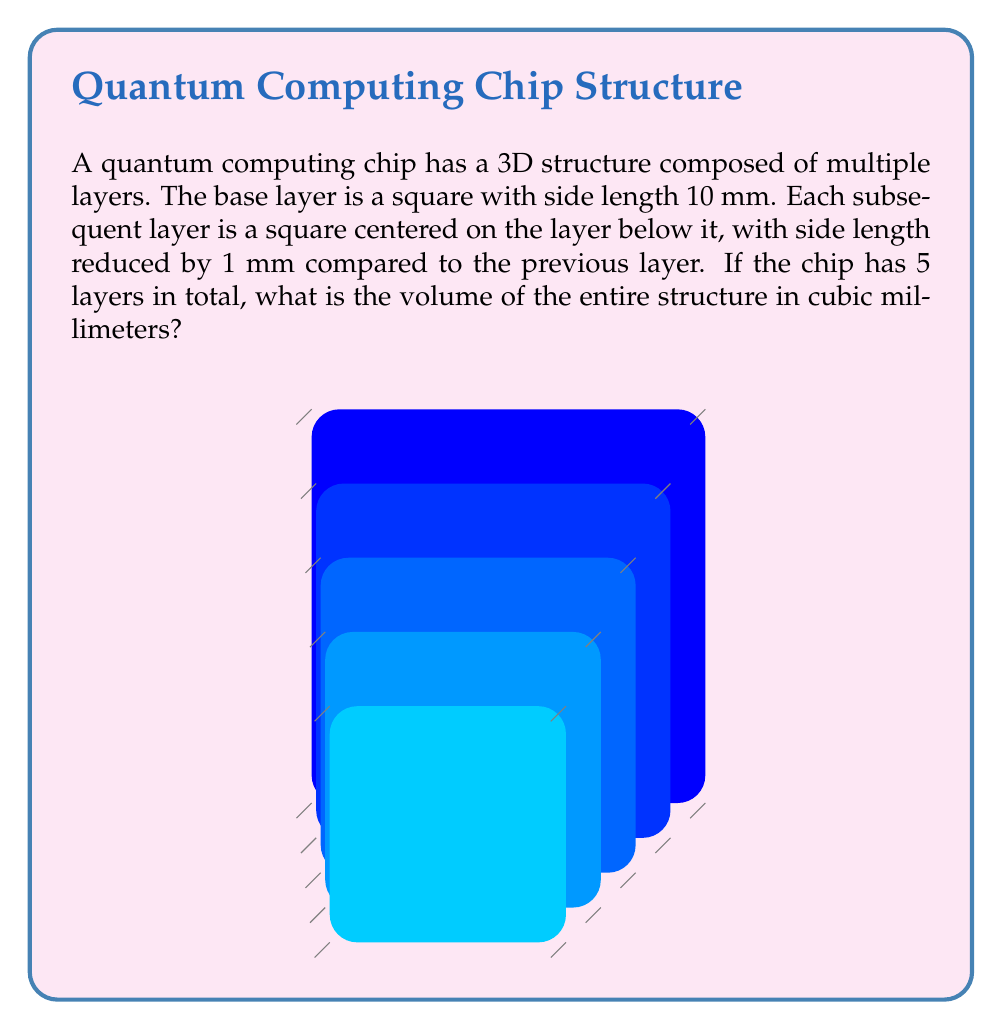What is the answer to this math problem? To solve this problem, we need to calculate the volume of each layer and sum them up. Let's break it down step by step:

1) The layers have the following dimensions:
   Layer 1 (bottom): 10 mm x 10 mm
   Layer 2: 9 mm x 9 mm
   Layer 3: 8 mm x 8 mm
   Layer 4: 7 mm x 7 mm
   Layer 5 (top): 6 mm x 6 mm

2) Each layer has a height of 1 mm.

3) The volume of each layer can be calculated using the formula:
   $V = l \times w \times h$
   where $l$ is length, $w$ is width, and $h$ is height.

4) Let's calculate the volume of each layer:
   Layer 1: $V_1 = 10 \times 10 \times 1 = 100$ mm³
   Layer 2: $V_2 = 9 \times 9 \times 1 = 81$ mm³
   Layer 3: $V_3 = 8 \times 8 \times 1 = 64$ mm³
   Layer 4: $V_4 = 7 \times 7 \times 1 = 49$ mm³
   Layer 5: $V_5 = 6 \times 6 \times 1 = 36$ mm³

5) The total volume is the sum of all layer volumes:

   $V_{total} = V_1 + V_2 + V_3 + V_4 + V_5$

   $V_{total} = 100 + 81 + 64 + 49 + 36 = 330$ mm³

Therefore, the total volume of the quantum computing chip is 330 cubic millimeters.
Answer: 330 mm³ 